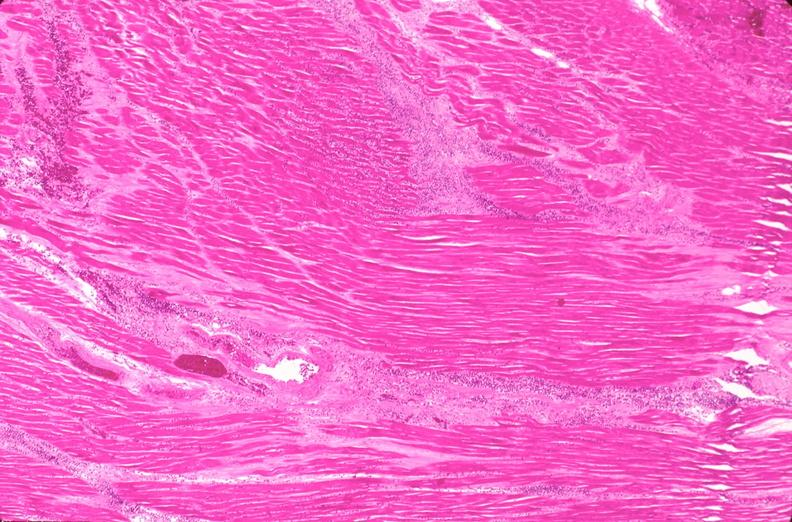s polycystic disease present?
Answer the question using a single word or phrase. No 